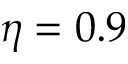Convert formula to latex. <formula><loc_0><loc_0><loc_500><loc_500>\eta = 0 . 9</formula> 